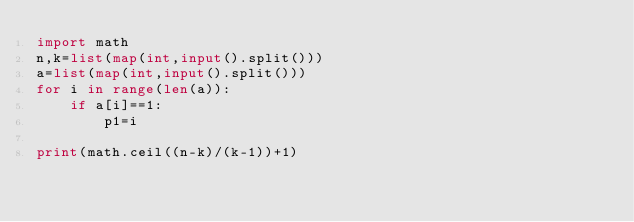Convert code to text. <code><loc_0><loc_0><loc_500><loc_500><_Python_>import math
n,k=list(map(int,input().split()))
a=list(map(int,input().split()))
for i in range(len(a)):
    if a[i]==1:
        p1=i

print(math.ceil((n-k)/(k-1))+1)
</code> 